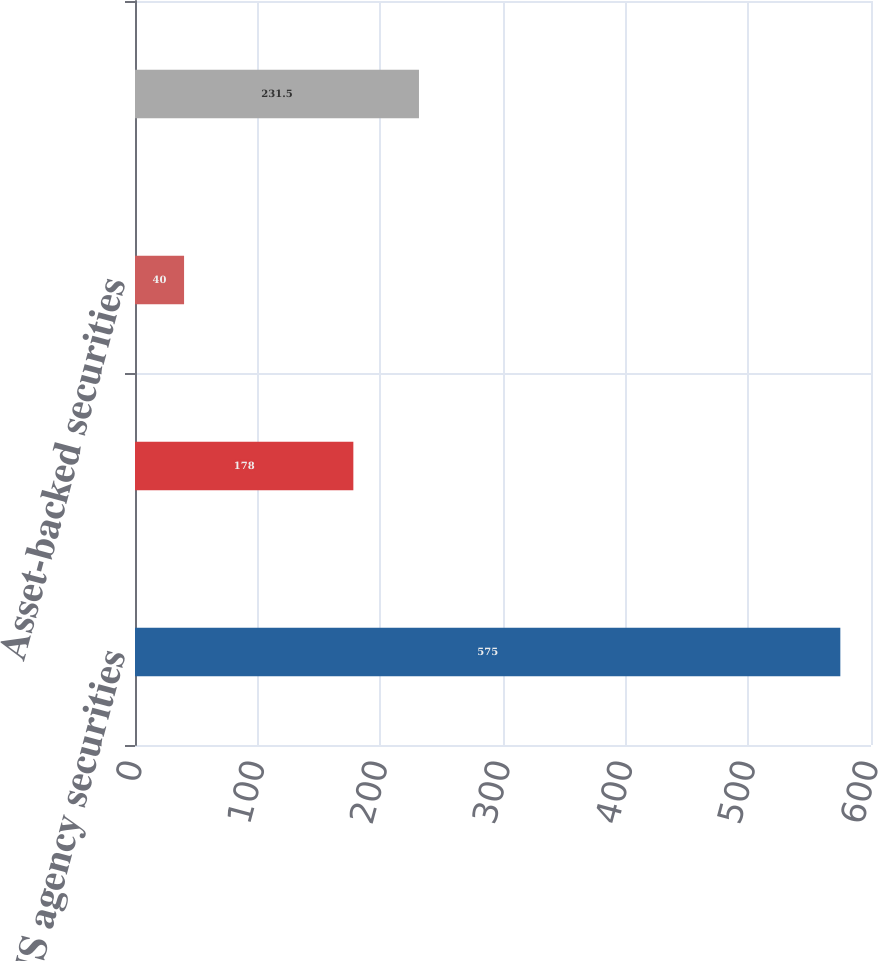<chart> <loc_0><loc_0><loc_500><loc_500><bar_chart><fcel>US agency securities<fcel>Corporate bonds<fcel>Asset-backed securities<fcel>US Treasury securities<nl><fcel>575<fcel>178<fcel>40<fcel>231.5<nl></chart> 